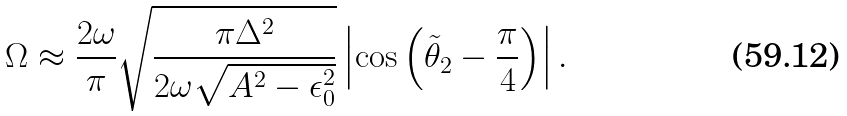Convert formula to latex. <formula><loc_0><loc_0><loc_500><loc_500>\Omega \approx \frac { 2 \omega } { \pi } \sqrt { \frac { \pi \Delta ^ { 2 } } { 2 \omega \sqrt { A ^ { 2 } - \epsilon _ { 0 } ^ { 2 } } } } \left | \cos \left ( \tilde { \theta } _ { 2 } - \frac { \pi } { 4 } \right ) \right | .</formula> 